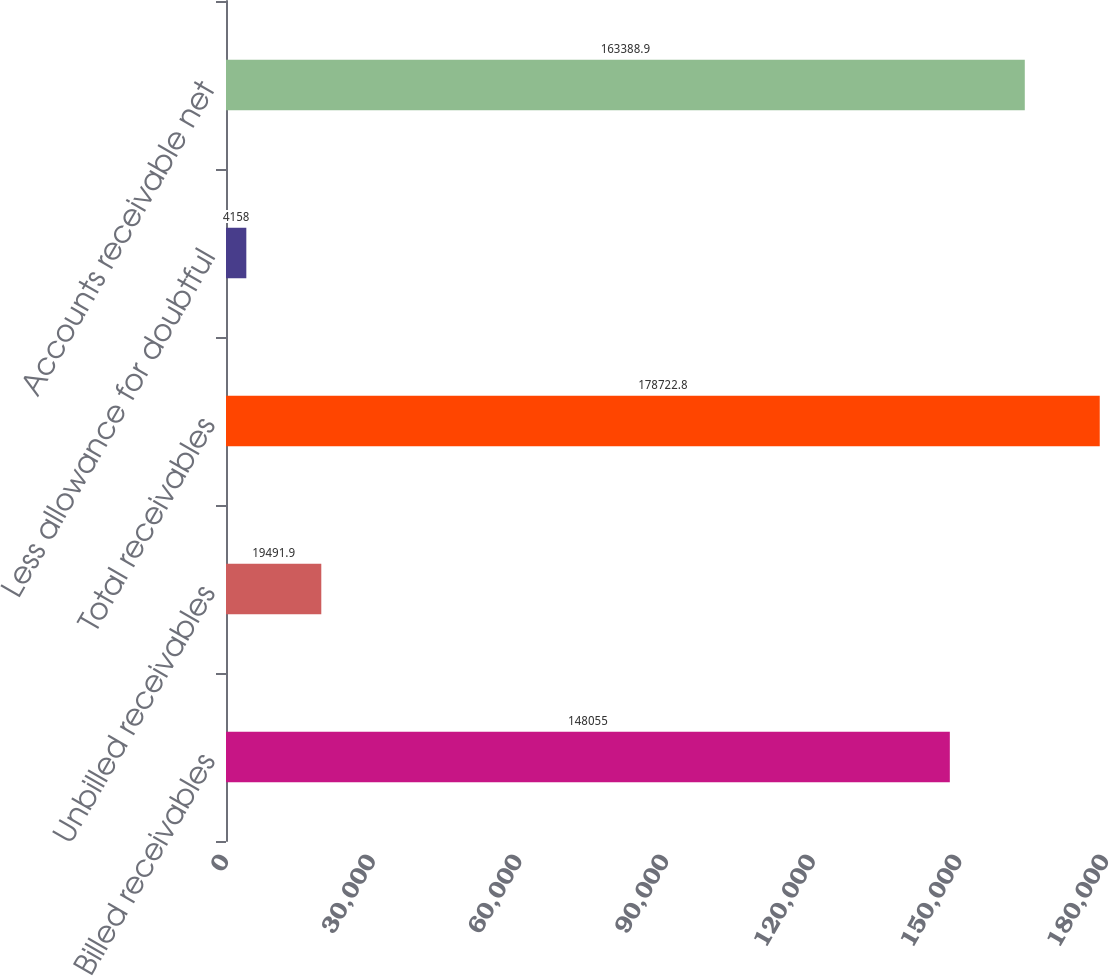<chart> <loc_0><loc_0><loc_500><loc_500><bar_chart><fcel>Billed receivables<fcel>Unbilled receivables<fcel>Total receivables<fcel>Less allowance for doubtful<fcel>Accounts receivable net<nl><fcel>148055<fcel>19491.9<fcel>178723<fcel>4158<fcel>163389<nl></chart> 